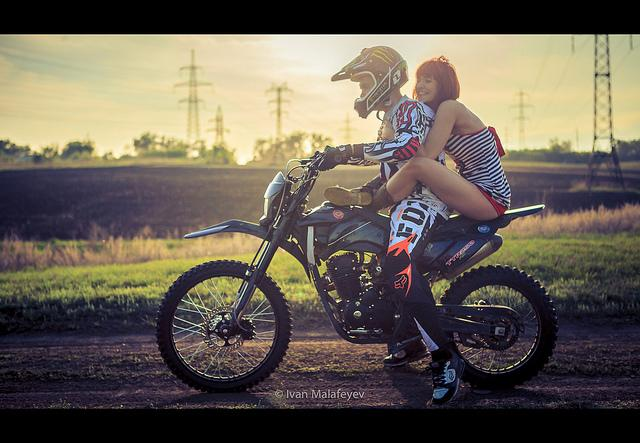Who is wearing the most safety gear? driver 